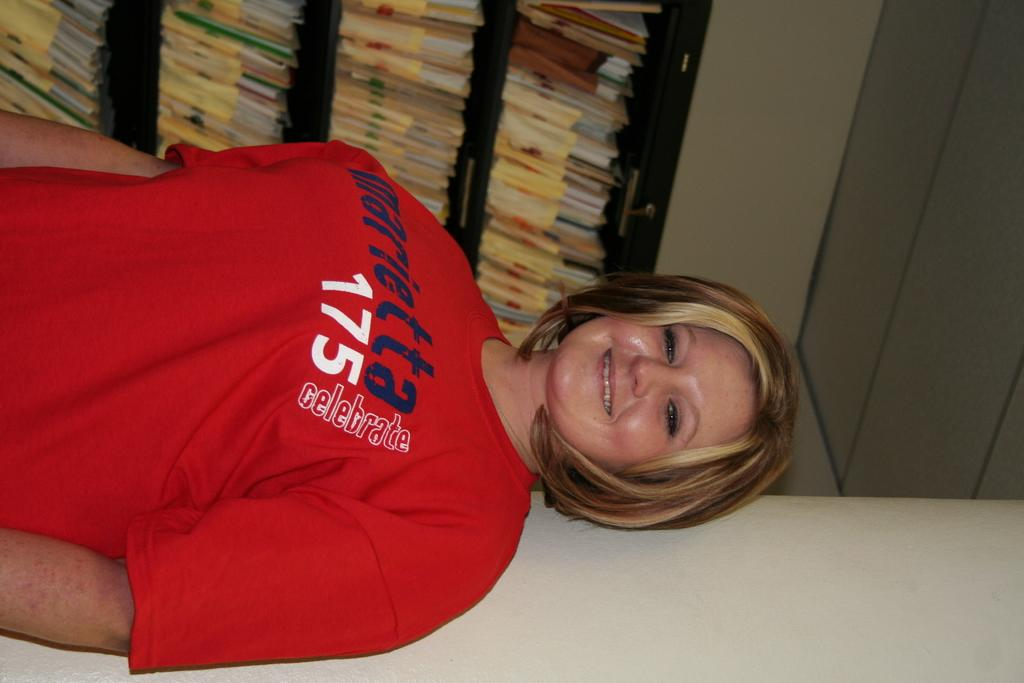<image>
Give a short and clear explanation of the subsequent image. A woman is wearing a red shirt with the number 175 on it. 